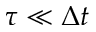Convert formula to latex. <formula><loc_0><loc_0><loc_500><loc_500>\tau \ll \Delta t</formula> 